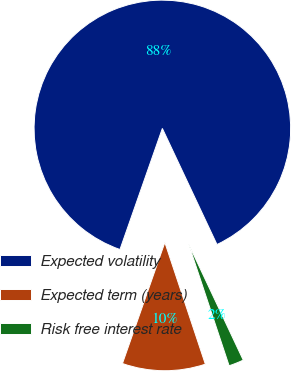Convert chart to OTSL. <chart><loc_0><loc_0><loc_500><loc_500><pie_chart><fcel>Expected volatility<fcel>Expected term (years)<fcel>Risk free interest rate<nl><fcel>87.63%<fcel>10.47%<fcel>1.89%<nl></chart> 